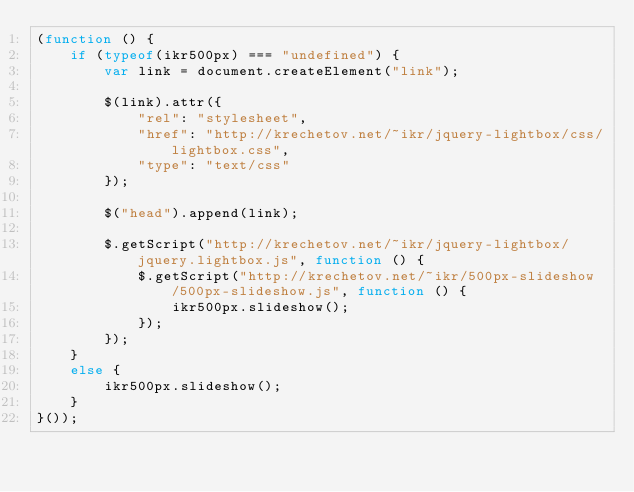<code> <loc_0><loc_0><loc_500><loc_500><_JavaScript_>(function () {
    if (typeof(ikr500px) === "undefined") {
        var link = document.createElement("link");

        $(link).attr({
            "rel": "stylesheet",
            "href": "http://krechetov.net/~ikr/jquery-lightbox/css/lightbox.css",
            "type": "text/css"
        });
    
        $("head").append(link);

        $.getScript("http://krechetov.net/~ikr/jquery-lightbox/jquery.lightbox.js", function () {
            $.getScript("http://krechetov.net/~ikr/500px-slideshow/500px-slideshow.js", function () {
                ikr500px.slideshow();
            });
        });
    }
    else {
        ikr500px.slideshow();
    }
}());</code> 